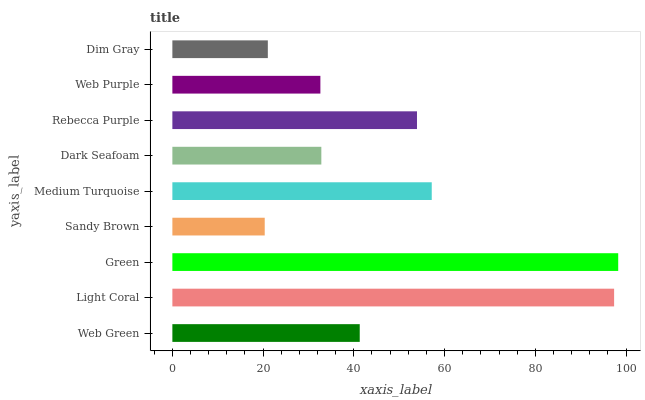Is Sandy Brown the minimum?
Answer yes or no. Yes. Is Green the maximum?
Answer yes or no. Yes. Is Light Coral the minimum?
Answer yes or no. No. Is Light Coral the maximum?
Answer yes or no. No. Is Light Coral greater than Web Green?
Answer yes or no. Yes. Is Web Green less than Light Coral?
Answer yes or no. Yes. Is Web Green greater than Light Coral?
Answer yes or no. No. Is Light Coral less than Web Green?
Answer yes or no. No. Is Web Green the high median?
Answer yes or no. Yes. Is Web Green the low median?
Answer yes or no. Yes. Is Dark Seafoam the high median?
Answer yes or no. No. Is Sandy Brown the low median?
Answer yes or no. No. 